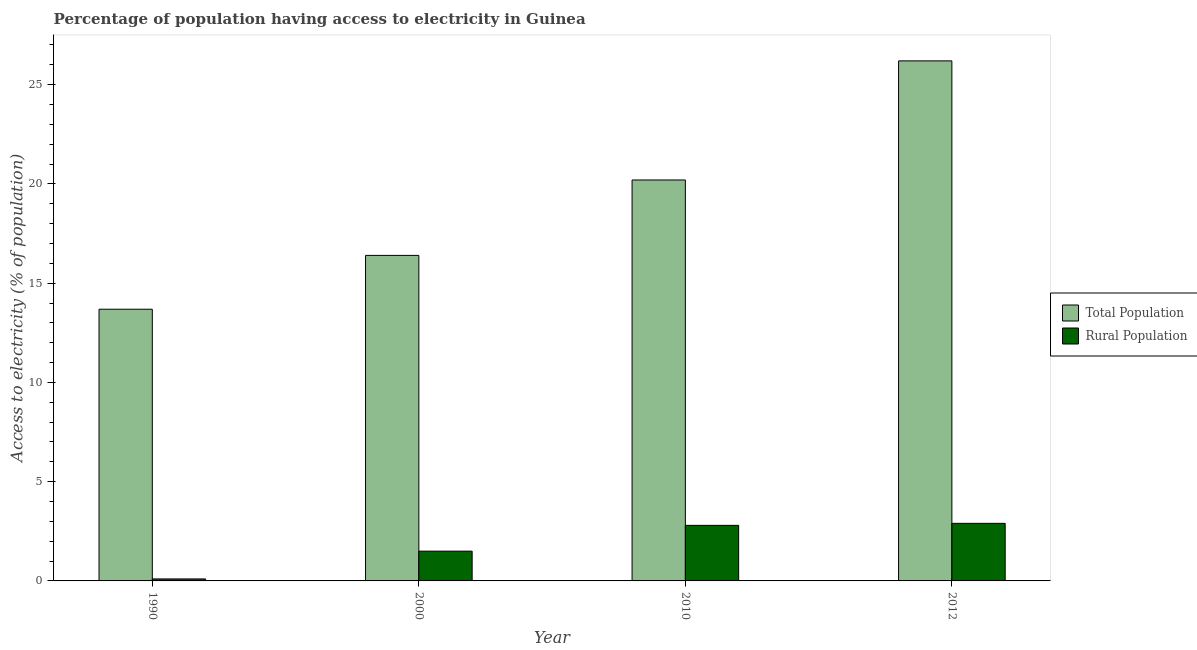How many groups of bars are there?
Your answer should be very brief. 4. Are the number of bars per tick equal to the number of legend labels?
Offer a terse response. Yes. What is the label of the 2nd group of bars from the left?
Offer a terse response. 2000. What is the percentage of rural population having access to electricity in 2012?
Make the answer very short. 2.9. Across all years, what is the maximum percentage of rural population having access to electricity?
Provide a succinct answer. 2.9. Across all years, what is the minimum percentage of population having access to electricity?
Your answer should be compact. 13.69. In which year was the percentage of rural population having access to electricity maximum?
Your answer should be compact. 2012. What is the total percentage of rural population having access to electricity in the graph?
Offer a terse response. 7.3. What is the difference between the percentage of rural population having access to electricity in 2000 and the percentage of population having access to electricity in 2010?
Offer a terse response. -1.3. What is the average percentage of population having access to electricity per year?
Your answer should be compact. 19.12. In the year 2010, what is the difference between the percentage of population having access to electricity and percentage of rural population having access to electricity?
Offer a very short reply. 0. What is the ratio of the percentage of rural population having access to electricity in 1990 to that in 2000?
Keep it short and to the point. 0.07. Is the percentage of population having access to electricity in 2000 less than that in 2012?
Give a very brief answer. Yes. Is the difference between the percentage of population having access to electricity in 2010 and 2012 greater than the difference between the percentage of rural population having access to electricity in 2010 and 2012?
Ensure brevity in your answer.  No. In how many years, is the percentage of population having access to electricity greater than the average percentage of population having access to electricity taken over all years?
Keep it short and to the point. 2. What does the 1st bar from the left in 2012 represents?
Offer a terse response. Total Population. What does the 2nd bar from the right in 2012 represents?
Ensure brevity in your answer.  Total Population. How many bars are there?
Offer a very short reply. 8. Are the values on the major ticks of Y-axis written in scientific E-notation?
Make the answer very short. No. Does the graph contain grids?
Offer a very short reply. No. Where does the legend appear in the graph?
Your response must be concise. Center right. How many legend labels are there?
Provide a succinct answer. 2. What is the title of the graph?
Offer a terse response. Percentage of population having access to electricity in Guinea. Does "Exports" appear as one of the legend labels in the graph?
Make the answer very short. No. What is the label or title of the Y-axis?
Keep it short and to the point. Access to electricity (% of population). What is the Access to electricity (% of population) in Total Population in 1990?
Offer a very short reply. 13.69. What is the Access to electricity (% of population) in Total Population in 2010?
Provide a short and direct response. 20.2. What is the Access to electricity (% of population) in Total Population in 2012?
Your answer should be compact. 26.2. Across all years, what is the maximum Access to electricity (% of population) of Total Population?
Your answer should be very brief. 26.2. Across all years, what is the maximum Access to electricity (% of population) in Rural Population?
Provide a short and direct response. 2.9. Across all years, what is the minimum Access to electricity (% of population) in Total Population?
Keep it short and to the point. 13.69. What is the total Access to electricity (% of population) of Total Population in the graph?
Your response must be concise. 76.49. What is the difference between the Access to electricity (% of population) of Total Population in 1990 and that in 2000?
Your response must be concise. -2.71. What is the difference between the Access to electricity (% of population) of Rural Population in 1990 and that in 2000?
Your answer should be very brief. -1.4. What is the difference between the Access to electricity (% of population) of Total Population in 1990 and that in 2010?
Offer a terse response. -6.51. What is the difference between the Access to electricity (% of population) in Total Population in 1990 and that in 2012?
Give a very brief answer. -12.51. What is the difference between the Access to electricity (% of population) of Rural Population in 1990 and that in 2012?
Give a very brief answer. -2.8. What is the difference between the Access to electricity (% of population) of Total Population in 2000 and that in 2010?
Keep it short and to the point. -3.8. What is the difference between the Access to electricity (% of population) of Rural Population in 2000 and that in 2010?
Offer a very short reply. -1.3. What is the difference between the Access to electricity (% of population) in Total Population in 2000 and that in 2012?
Your answer should be compact. -9.8. What is the difference between the Access to electricity (% of population) of Rural Population in 2000 and that in 2012?
Offer a very short reply. -1.4. What is the difference between the Access to electricity (% of population) of Total Population in 2010 and that in 2012?
Provide a succinct answer. -6. What is the difference between the Access to electricity (% of population) in Rural Population in 2010 and that in 2012?
Your response must be concise. -0.1. What is the difference between the Access to electricity (% of population) in Total Population in 1990 and the Access to electricity (% of population) in Rural Population in 2000?
Offer a very short reply. 12.19. What is the difference between the Access to electricity (% of population) in Total Population in 1990 and the Access to electricity (% of population) in Rural Population in 2010?
Offer a terse response. 10.89. What is the difference between the Access to electricity (% of population) in Total Population in 1990 and the Access to electricity (% of population) in Rural Population in 2012?
Offer a very short reply. 10.79. What is the difference between the Access to electricity (% of population) in Total Population in 2000 and the Access to electricity (% of population) in Rural Population in 2012?
Your answer should be compact. 13.5. What is the difference between the Access to electricity (% of population) in Total Population in 2010 and the Access to electricity (% of population) in Rural Population in 2012?
Give a very brief answer. 17.3. What is the average Access to electricity (% of population) of Total Population per year?
Your answer should be compact. 19.12. What is the average Access to electricity (% of population) of Rural Population per year?
Make the answer very short. 1.82. In the year 1990, what is the difference between the Access to electricity (% of population) in Total Population and Access to electricity (% of population) in Rural Population?
Ensure brevity in your answer.  13.59. In the year 2000, what is the difference between the Access to electricity (% of population) of Total Population and Access to electricity (% of population) of Rural Population?
Provide a succinct answer. 14.9. In the year 2010, what is the difference between the Access to electricity (% of population) of Total Population and Access to electricity (% of population) of Rural Population?
Make the answer very short. 17.4. In the year 2012, what is the difference between the Access to electricity (% of population) of Total Population and Access to electricity (% of population) of Rural Population?
Provide a succinct answer. 23.3. What is the ratio of the Access to electricity (% of population) in Total Population in 1990 to that in 2000?
Provide a short and direct response. 0.83. What is the ratio of the Access to electricity (% of population) of Rural Population in 1990 to that in 2000?
Your response must be concise. 0.07. What is the ratio of the Access to electricity (% of population) in Total Population in 1990 to that in 2010?
Make the answer very short. 0.68. What is the ratio of the Access to electricity (% of population) of Rural Population in 1990 to that in 2010?
Offer a terse response. 0.04. What is the ratio of the Access to electricity (% of population) of Total Population in 1990 to that in 2012?
Offer a very short reply. 0.52. What is the ratio of the Access to electricity (% of population) in Rural Population in 1990 to that in 2012?
Your response must be concise. 0.03. What is the ratio of the Access to electricity (% of population) in Total Population in 2000 to that in 2010?
Ensure brevity in your answer.  0.81. What is the ratio of the Access to electricity (% of population) of Rural Population in 2000 to that in 2010?
Your answer should be compact. 0.54. What is the ratio of the Access to electricity (% of population) in Total Population in 2000 to that in 2012?
Give a very brief answer. 0.63. What is the ratio of the Access to electricity (% of population) in Rural Population in 2000 to that in 2012?
Your response must be concise. 0.52. What is the ratio of the Access to electricity (% of population) of Total Population in 2010 to that in 2012?
Provide a succinct answer. 0.77. What is the ratio of the Access to electricity (% of population) of Rural Population in 2010 to that in 2012?
Provide a short and direct response. 0.97. What is the difference between the highest and the second highest Access to electricity (% of population) in Total Population?
Keep it short and to the point. 6. What is the difference between the highest and the lowest Access to electricity (% of population) in Total Population?
Keep it short and to the point. 12.51. What is the difference between the highest and the lowest Access to electricity (% of population) in Rural Population?
Offer a terse response. 2.8. 